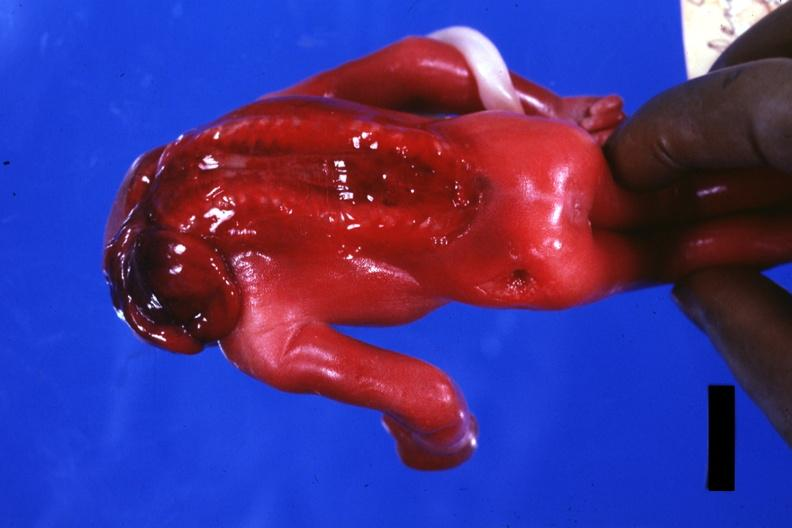does this image show posterior view open cord?
Answer the question using a single word or phrase. Yes 